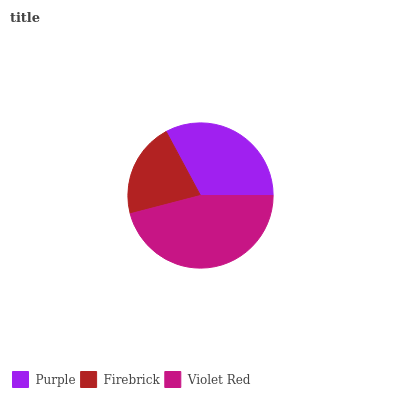Is Firebrick the minimum?
Answer yes or no. Yes. Is Violet Red the maximum?
Answer yes or no. Yes. Is Violet Red the minimum?
Answer yes or no. No. Is Firebrick the maximum?
Answer yes or no. No. Is Violet Red greater than Firebrick?
Answer yes or no. Yes. Is Firebrick less than Violet Red?
Answer yes or no. Yes. Is Firebrick greater than Violet Red?
Answer yes or no. No. Is Violet Red less than Firebrick?
Answer yes or no. No. Is Purple the high median?
Answer yes or no. Yes. Is Purple the low median?
Answer yes or no. Yes. Is Violet Red the high median?
Answer yes or no. No. Is Firebrick the low median?
Answer yes or no. No. 